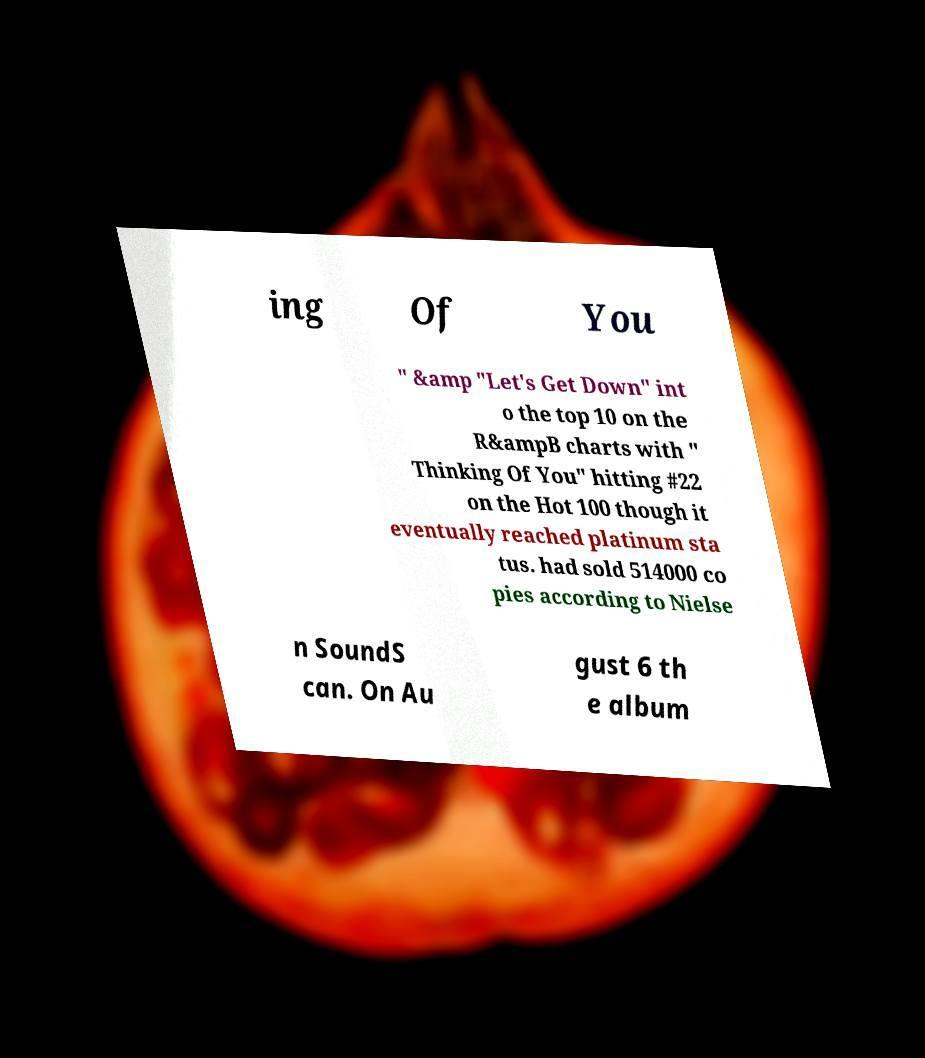I need the written content from this picture converted into text. Can you do that? ing Of You " &amp "Let's Get Down" int o the top 10 on the R&ampB charts with " Thinking Of You" hitting #22 on the Hot 100 though it eventually reached platinum sta tus. had sold 514000 co pies according to Nielse n SoundS can. On Au gust 6 th e album 